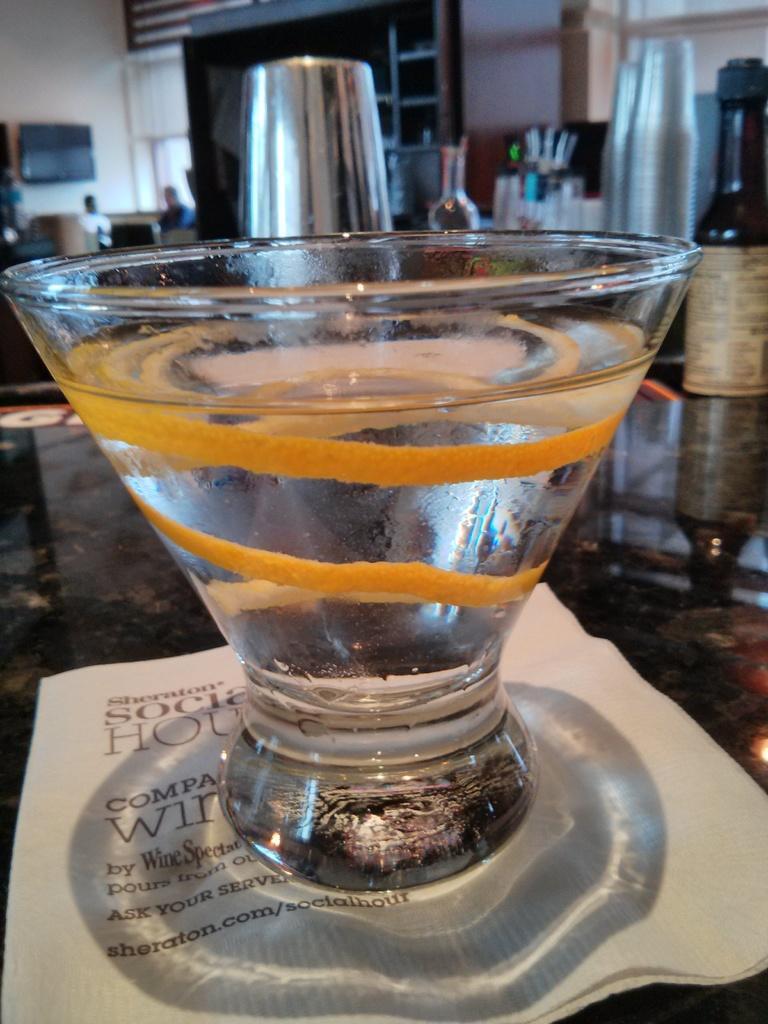Please provide a concise description of this image. In this image there is a glass, bottle, people, television, rack, table and objects. 